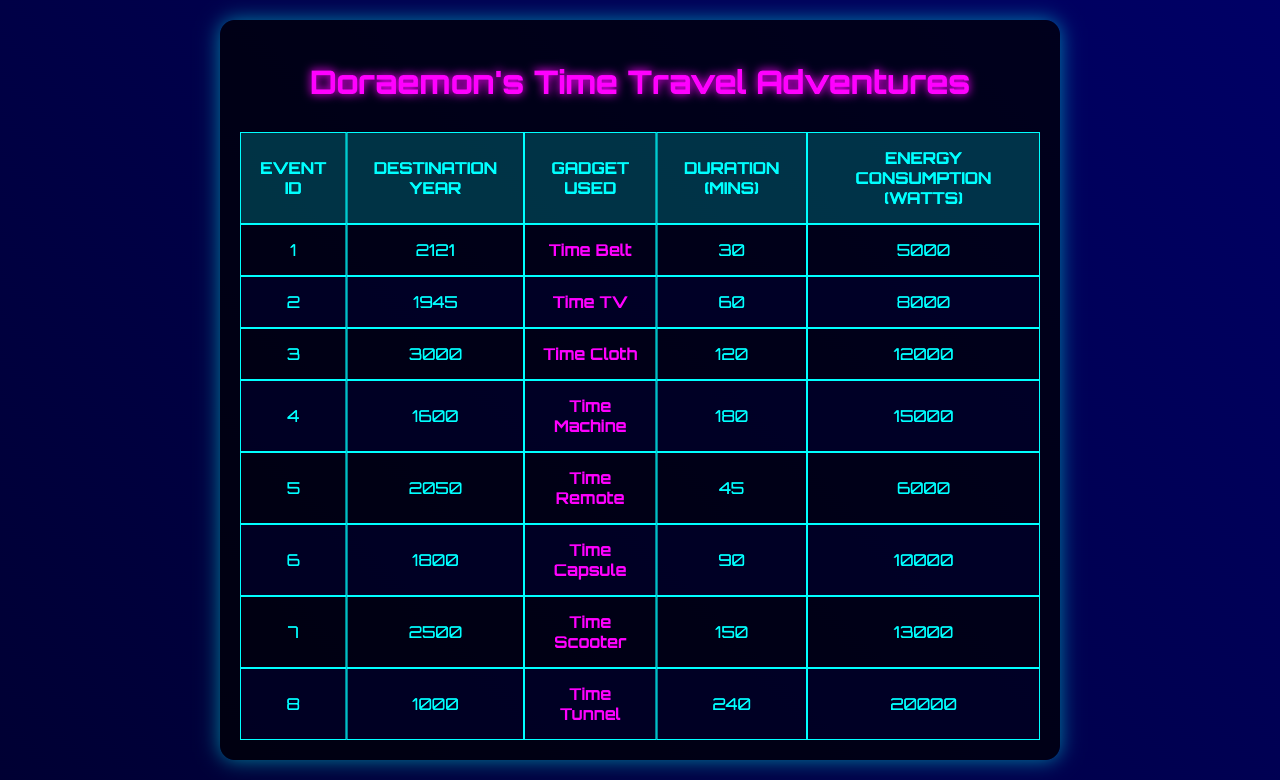What gadget was used for the time travel event to the year 2121? Referring to the table, the entry for the event with ID 1 shows that the gadget used for traveling to the year 2121 is the "Time Belt."
Answer: Time Belt What is the duration of the time travel event to the year 1800? Looking at the table, the event for the year 1800 (event ID 6) has a duration of 90 minutes listed under the "Duration (mins)" column.
Answer: 90 minutes Which time travel events consumed more than 10,000 watts? By inspecting the "Energy Consumption (watts)" column, the events with ID 3, 4, 6, and 8 consumed more than 10,000 watts (12,000, 15,000, 10,000, and 20,000 watts respectively).
Answer: Events ID 3, 4, and 8 What is the average duration of the time travel events recorded? The durations listed in the table are 30, 60, 120, 180, 45, 90, 150, and 240 minutes, totaling 975 minutes. Dividing by the number of events (8), the average duration is 975/8 = 121.875 minutes.
Answer: Approximately 121.88 minutes Is it true that the gadget used for the event in 1945 was the Time Capsule? Checking the table for event ID 2, it shows that the gadget used for traveling to 1945 is actually the "Time TV," not the Time Capsule.
Answer: No What event had the highest energy consumption, and how much was it? Looking through the "Energy Consumption (watts)" column, event ID 8 for the year 1000 had the highest consumption, which is 20,000 watts.
Answer: Event ID 8, 20,000 watts How many total minutes were spent on time travel to all listed years? Adding the durations from all events: 30 + 60 + 120 + 180 + 45 + 90 + 150 + 240 = 975 minutes spent on time travel.
Answer: 975 minutes What years did events using gadgets that consumed less than 10,000 watts take place? Checking the energy consumption for each event, only event IDs 1, 2, 5, and 6 used gadgets consuming less than 10,000 watts, corresponding to years 2121, 1945, 2050, and 1800 respectively.
Answer: 2121, 1945, 2050, 1800 Which gadget had the longest duration of use, and how long was it used for? Event ID 8 shows the "Time Tunnel" was used for the longest duration of 240 minutes, according to the "Duration (mins)" column.
Answer: Time Tunnel, 240 minutes How many events were recorded in the 2000s decade? The relevant events are event IDs 5 and 7, which correspond to the years 2050 and 2500, giving a total of 2 events recorded during the 2000s decade.
Answer: 2 events 